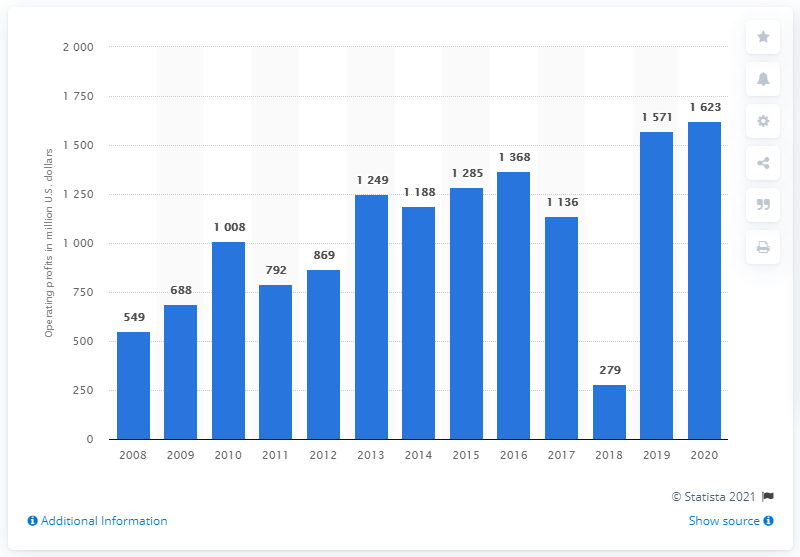Highlight a few significant elements in this photo. In 2020, Whirlpool's operating profit was 1,623. 